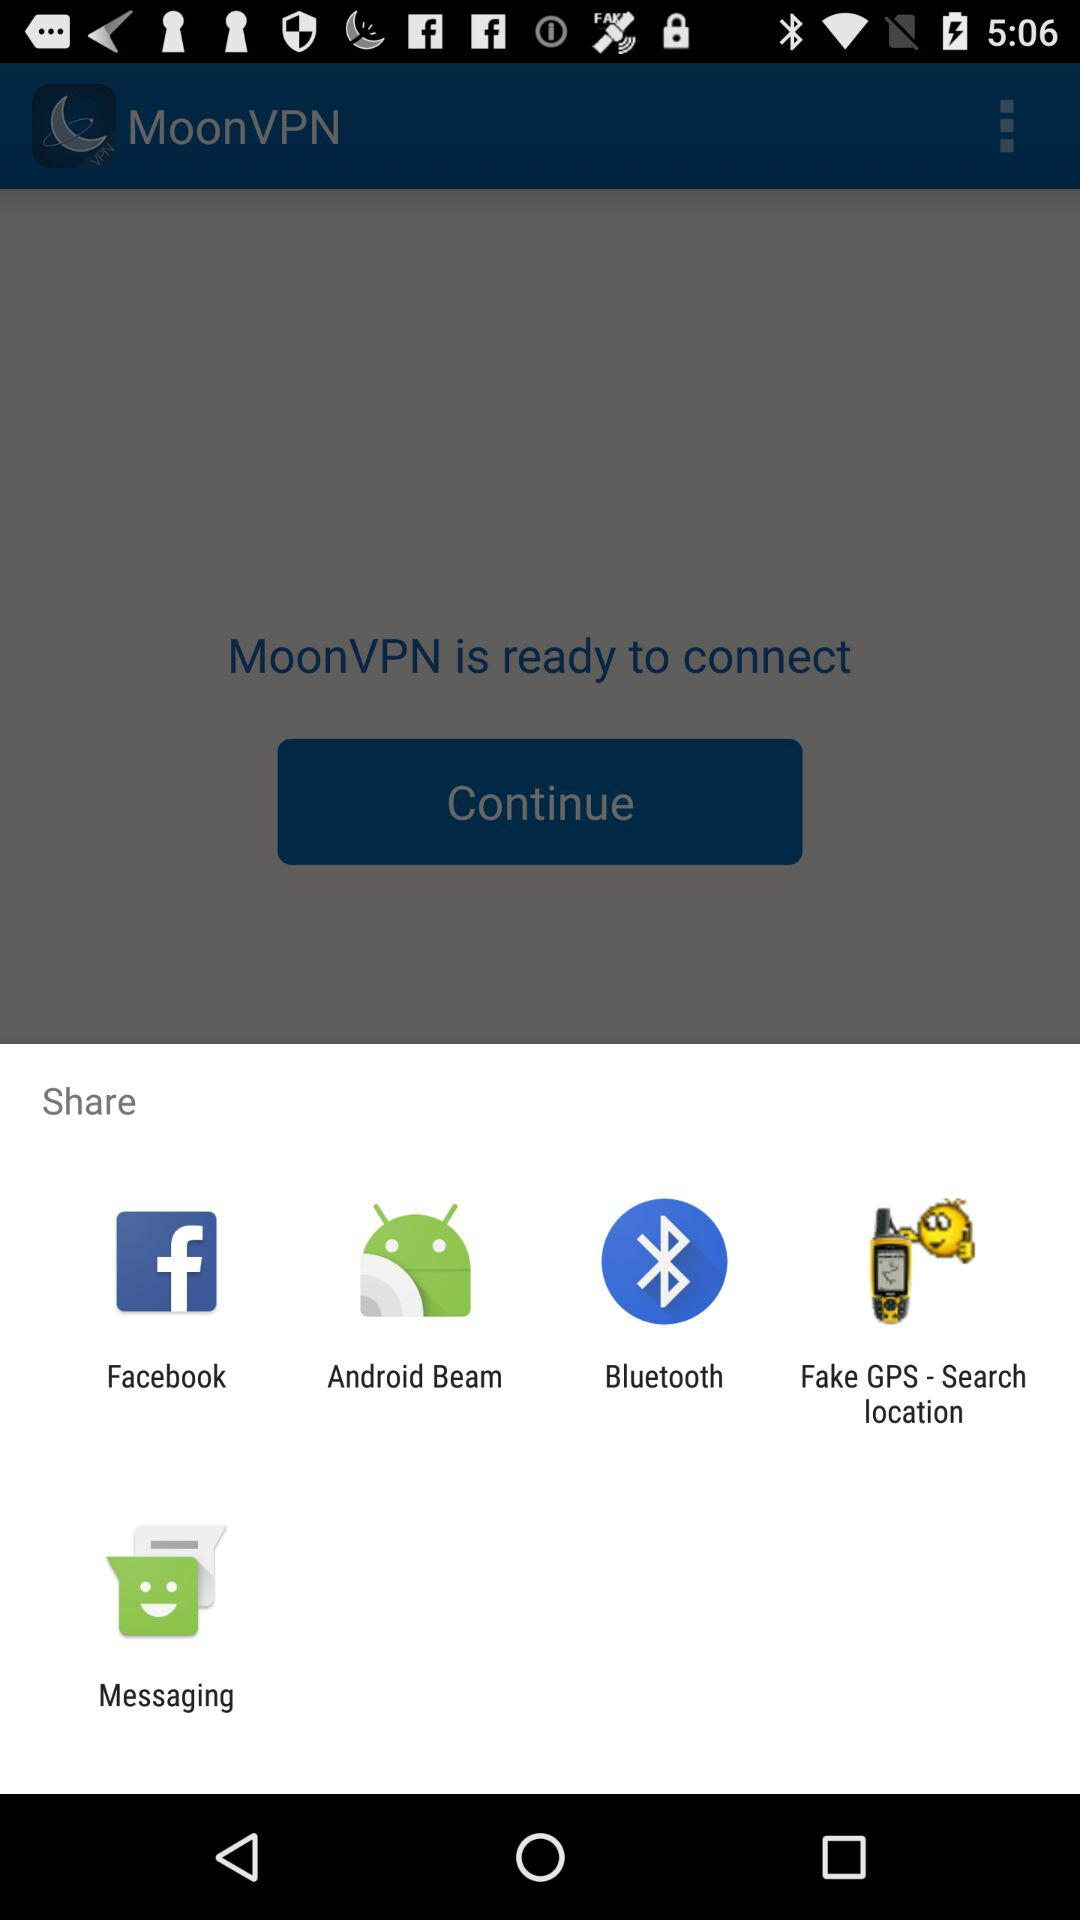What are the different sharing options? The different sharing options are "Facebook", "Android Beam", "Bluetooth", "Fake GPS - Search location" and "Messaging". 